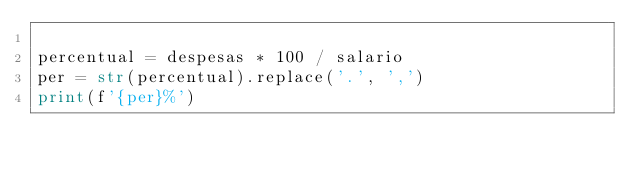<code> <loc_0><loc_0><loc_500><loc_500><_Python_>
percentual = despesas * 100 / salario
per = str(percentual).replace('.', ',')
print(f'{per}%')

</code> 